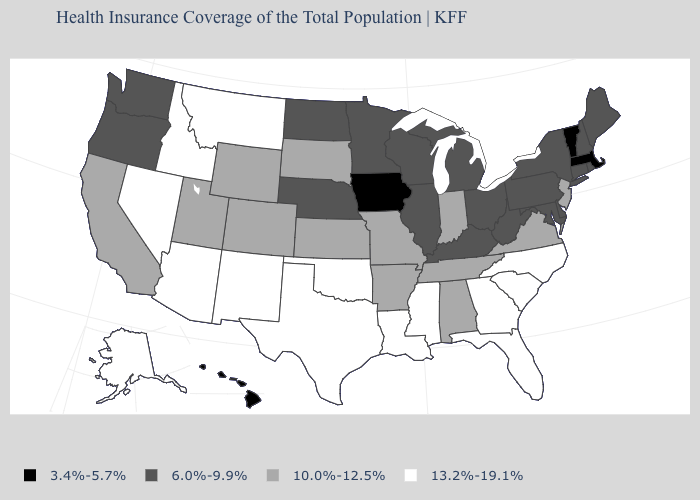What is the value of Colorado?
Give a very brief answer. 10.0%-12.5%. Name the states that have a value in the range 13.2%-19.1%?
Concise answer only. Alaska, Arizona, Florida, Georgia, Idaho, Louisiana, Mississippi, Montana, Nevada, New Mexico, North Carolina, Oklahoma, South Carolina, Texas. Which states have the lowest value in the MidWest?
Answer briefly. Iowa. What is the value of Virginia?
Be succinct. 10.0%-12.5%. What is the value of Arkansas?
Be succinct. 10.0%-12.5%. Among the states that border Minnesota , which have the lowest value?
Give a very brief answer. Iowa. Is the legend a continuous bar?
Keep it brief. No. Does New York have the lowest value in the Northeast?
Be succinct. No. Does Florida have a higher value than New Mexico?
Short answer required. No. What is the value of Louisiana?
Answer briefly. 13.2%-19.1%. Name the states that have a value in the range 10.0%-12.5%?
Answer briefly. Alabama, Arkansas, California, Colorado, Indiana, Kansas, Missouri, New Jersey, South Dakota, Tennessee, Utah, Virginia, Wyoming. Which states have the lowest value in the USA?
Short answer required. Hawaii, Iowa, Massachusetts, Vermont. Is the legend a continuous bar?
Quick response, please. No. Name the states that have a value in the range 6.0%-9.9%?
Concise answer only. Connecticut, Delaware, Illinois, Kentucky, Maine, Maryland, Michigan, Minnesota, Nebraska, New Hampshire, New York, North Dakota, Ohio, Oregon, Pennsylvania, Rhode Island, Washington, West Virginia, Wisconsin. Among the states that border Kentucky , which have the lowest value?
Give a very brief answer. Illinois, Ohio, West Virginia. 